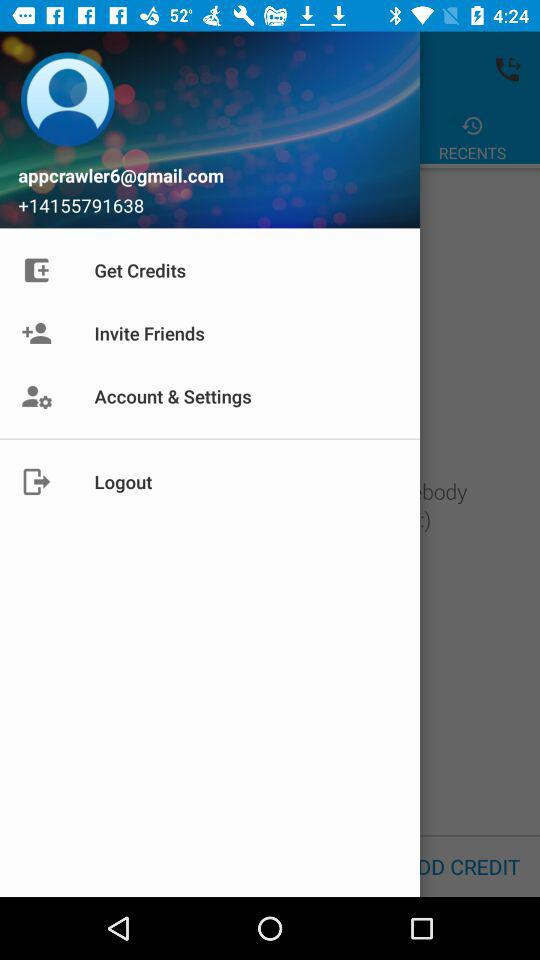What is the number given on the screen? The number given on the screen is +14155791638. 